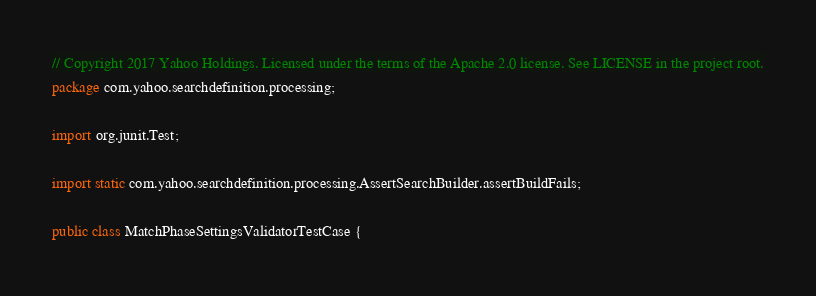Convert code to text. <code><loc_0><loc_0><loc_500><loc_500><_Java_>// Copyright 2017 Yahoo Holdings. Licensed under the terms of the Apache 2.0 license. See LICENSE in the project root.
package com.yahoo.searchdefinition.processing;

import org.junit.Test;

import static com.yahoo.searchdefinition.processing.AssertSearchBuilder.assertBuildFails;

public class MatchPhaseSettingsValidatorTestCase {
</code> 